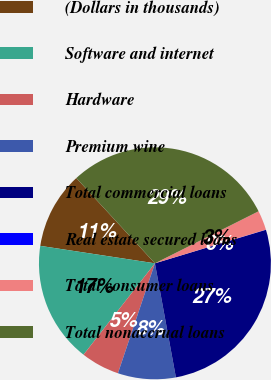<chart> <loc_0><loc_0><loc_500><loc_500><pie_chart><fcel>(Dollars in thousands)<fcel>Software and internet<fcel>Hardware<fcel>Premium wine<fcel>Total commercial loans<fcel>Real estate secured loans<fcel>Total consumer loans<fcel>Total nonaccrual loans<nl><fcel>10.74%<fcel>16.85%<fcel>5.39%<fcel>8.06%<fcel>26.77%<fcel>0.03%<fcel>2.71%<fcel>29.45%<nl></chart> 